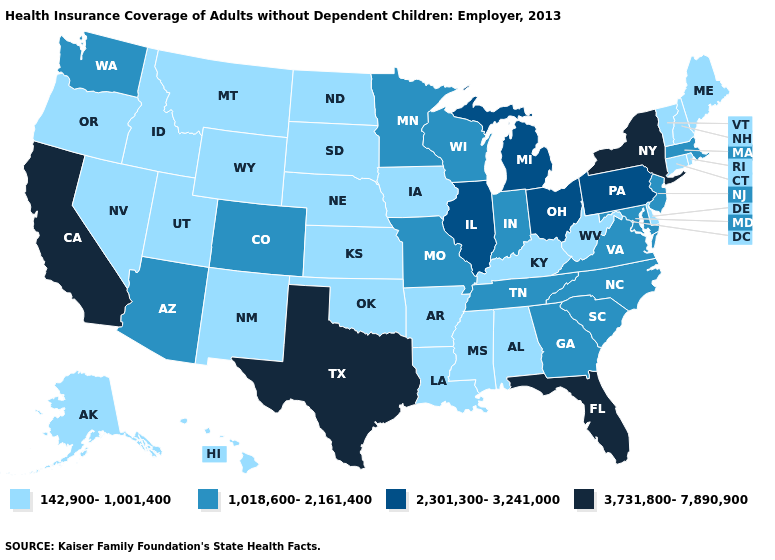Name the states that have a value in the range 1,018,600-2,161,400?
Keep it brief. Arizona, Colorado, Georgia, Indiana, Maryland, Massachusetts, Minnesota, Missouri, New Jersey, North Carolina, South Carolina, Tennessee, Virginia, Washington, Wisconsin. Name the states that have a value in the range 3,731,800-7,890,900?
Be succinct. California, Florida, New York, Texas. Name the states that have a value in the range 142,900-1,001,400?
Keep it brief. Alabama, Alaska, Arkansas, Connecticut, Delaware, Hawaii, Idaho, Iowa, Kansas, Kentucky, Louisiana, Maine, Mississippi, Montana, Nebraska, Nevada, New Hampshire, New Mexico, North Dakota, Oklahoma, Oregon, Rhode Island, South Dakota, Utah, Vermont, West Virginia, Wyoming. Among the states that border Michigan , does Ohio have the highest value?
Give a very brief answer. Yes. Name the states that have a value in the range 3,731,800-7,890,900?
Write a very short answer. California, Florida, New York, Texas. Does the first symbol in the legend represent the smallest category?
Be succinct. Yes. Which states have the highest value in the USA?
Answer briefly. California, Florida, New York, Texas. What is the value of Minnesota?
Be succinct. 1,018,600-2,161,400. Name the states that have a value in the range 1,018,600-2,161,400?
Quick response, please. Arizona, Colorado, Georgia, Indiana, Maryland, Massachusetts, Minnesota, Missouri, New Jersey, North Carolina, South Carolina, Tennessee, Virginia, Washington, Wisconsin. Is the legend a continuous bar?
Be succinct. No. What is the value of Pennsylvania?
Answer briefly. 2,301,300-3,241,000. Among the states that border Illinois , does Missouri have the lowest value?
Keep it brief. No. What is the highest value in the West ?
Quick response, please. 3,731,800-7,890,900. What is the lowest value in states that border Massachusetts?
Answer briefly. 142,900-1,001,400. Among the states that border Florida , which have the lowest value?
Be succinct. Alabama. 